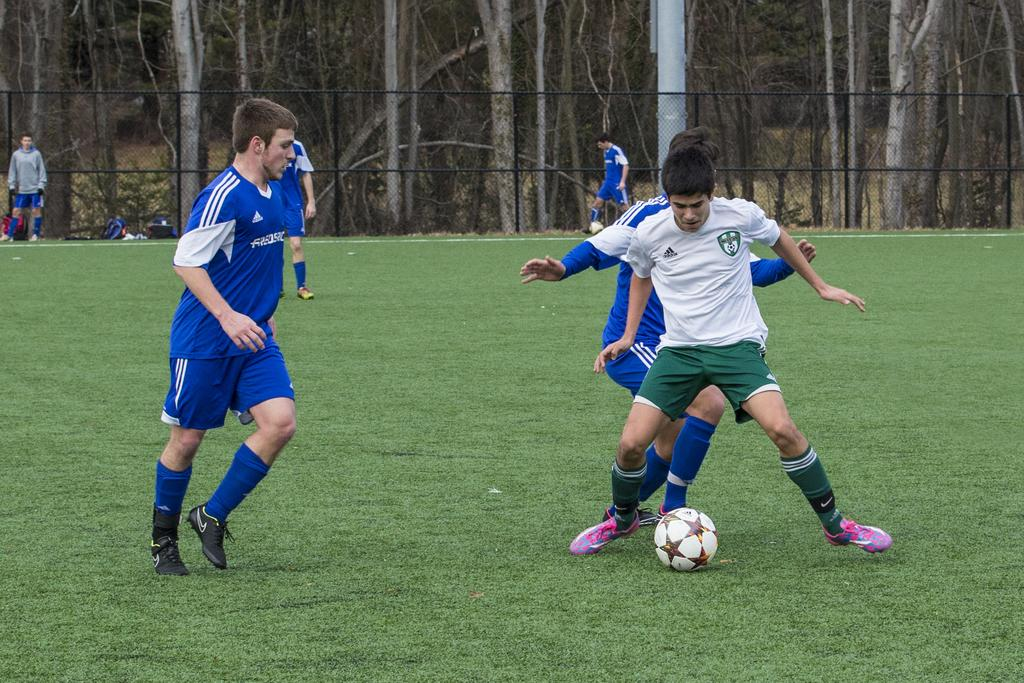What are the four persons in the image doing? The four persons are running on the grass. What object can be seen in the image besides the people? There is a ball in the image. What can be seen in the background of the image? Trees are visible in the distance. How many persons are standing in the image? Two persons are standing. What type of hall can be seen in the image? There is no hall present in the image. 